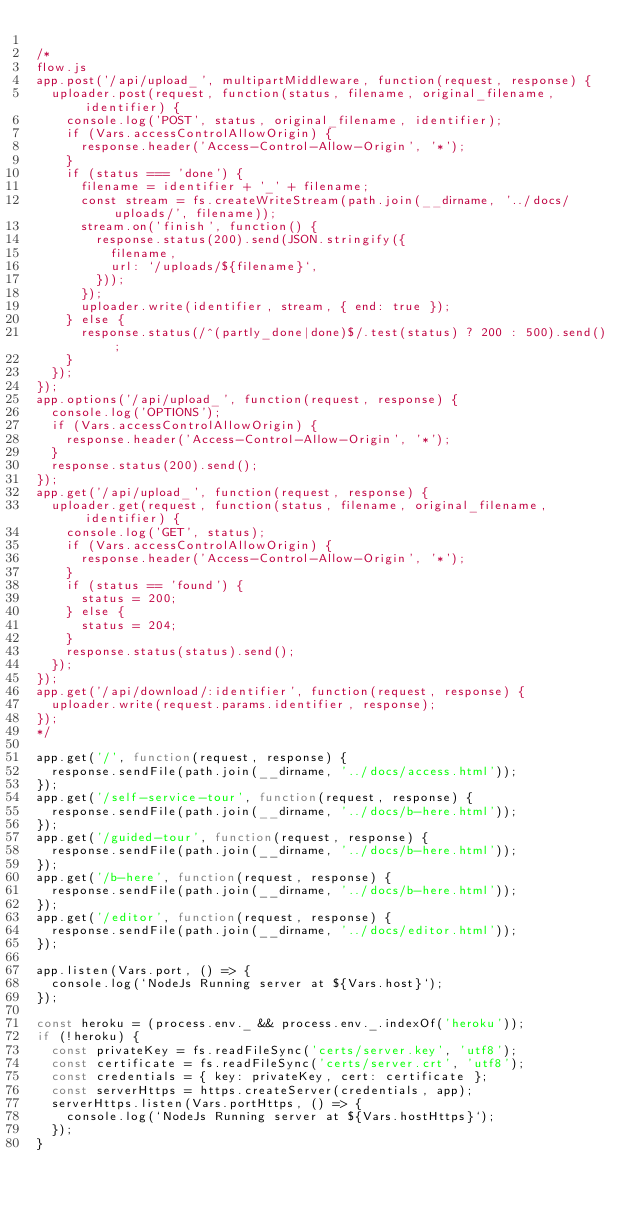<code> <loc_0><loc_0><loc_500><loc_500><_JavaScript_>
/*
flow.js
app.post('/api/upload_', multipartMiddleware, function(request, response) {
	uploader.post(request, function(status, filename, original_filename, identifier) {
		console.log('POST', status, original_filename, identifier);
		if (Vars.accessControlAllowOrigin) {
			response.header('Access-Control-Allow-Origin', '*');
		}
		if (status === 'done') {
			filename = identifier + '_' + filename;
			const stream = fs.createWriteStream(path.join(__dirname, '../docs/uploads/', filename));
			stream.on('finish', function() {
				response.status(200).send(JSON.stringify({
					filename,
					url: `/uploads/${filename}`,
				}));
			});
			uploader.write(identifier, stream, { end: true });
		} else {
			response.status(/^(partly_done|done)$/.test(status) ? 200 : 500).send();
		}
	});
});
app.options('/api/upload_', function(request, response) {
	console.log('OPTIONS');
	if (Vars.accessControlAllowOrigin) {
		response.header('Access-Control-Allow-Origin', '*');
	}
	response.status(200).send();
});
app.get('/api/upload_', function(request, response) {
	uploader.get(request, function(status, filename, original_filename, identifier) {
		console.log('GET', status);
		if (Vars.accessControlAllowOrigin) {
			response.header('Access-Control-Allow-Origin', '*');
		}
		if (status == 'found') {
			status = 200;
		} else {
			status = 204;
		}
		response.status(status).send();
	});
});
app.get('/api/download/:identifier', function(request, response) {
	uploader.write(request.params.identifier, response);
});
*/

app.get('/', function(request, response) {
	response.sendFile(path.join(__dirname, '../docs/access.html'));
});
app.get('/self-service-tour', function(request, response) {
	response.sendFile(path.join(__dirname, '../docs/b-here.html'));
});
app.get('/guided-tour', function(request, response) {
	response.sendFile(path.join(__dirname, '../docs/b-here.html'));
});
app.get('/b-here', function(request, response) {
	response.sendFile(path.join(__dirname, '../docs/b-here.html'));
});
app.get('/editor', function(request, response) {
	response.sendFile(path.join(__dirname, '../docs/editor.html'));
});

app.listen(Vars.port, () => {
	console.log(`NodeJs Running server at ${Vars.host}`);
});

const heroku = (process.env._ && process.env._.indexOf('heroku'));
if (!heroku) {
	const privateKey = fs.readFileSync('certs/server.key', 'utf8');
	const certificate = fs.readFileSync('certs/server.crt', 'utf8');
	const credentials = { key: privateKey, cert: certificate };
	const serverHttps = https.createServer(credentials, app);
	serverHttps.listen(Vars.portHttps, () => {
		console.log(`NodeJs Running server at ${Vars.hostHttps}`);
	});
}
</code> 